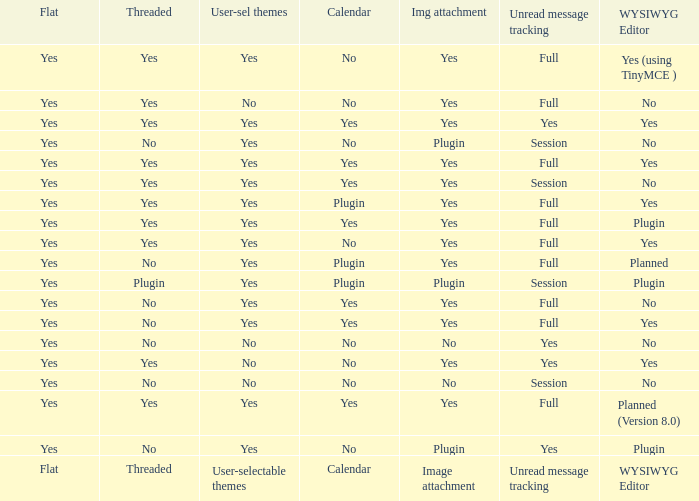Which WYSIWYG Editor has a User-selectable themes of yes, and an Unread message tracking of session, and an Image attachment of plugin? No, Plugin. 